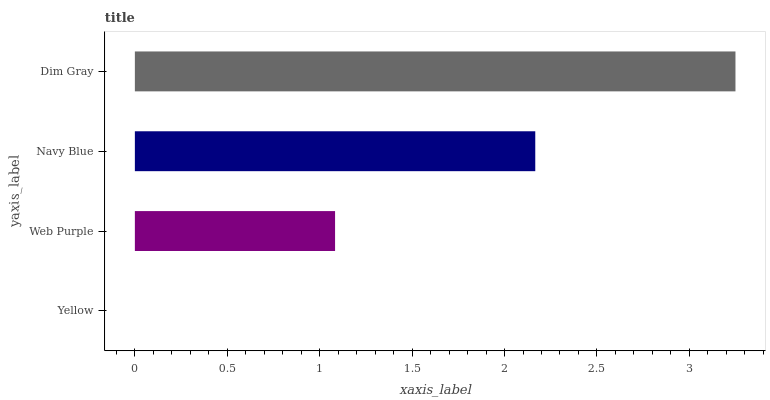Is Yellow the minimum?
Answer yes or no. Yes. Is Dim Gray the maximum?
Answer yes or no. Yes. Is Web Purple the minimum?
Answer yes or no. No. Is Web Purple the maximum?
Answer yes or no. No. Is Web Purple greater than Yellow?
Answer yes or no. Yes. Is Yellow less than Web Purple?
Answer yes or no. Yes. Is Yellow greater than Web Purple?
Answer yes or no. No. Is Web Purple less than Yellow?
Answer yes or no. No. Is Navy Blue the high median?
Answer yes or no. Yes. Is Web Purple the low median?
Answer yes or no. Yes. Is Dim Gray the high median?
Answer yes or no. No. Is Yellow the low median?
Answer yes or no. No. 